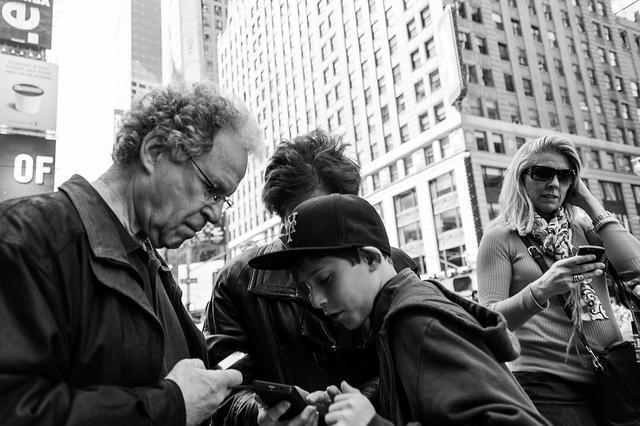What does the boy have on his head?
From the following four choices, select the correct answer to address the question.
Options: Baseball cap, cat, balloon, fedora. Baseball cap. 